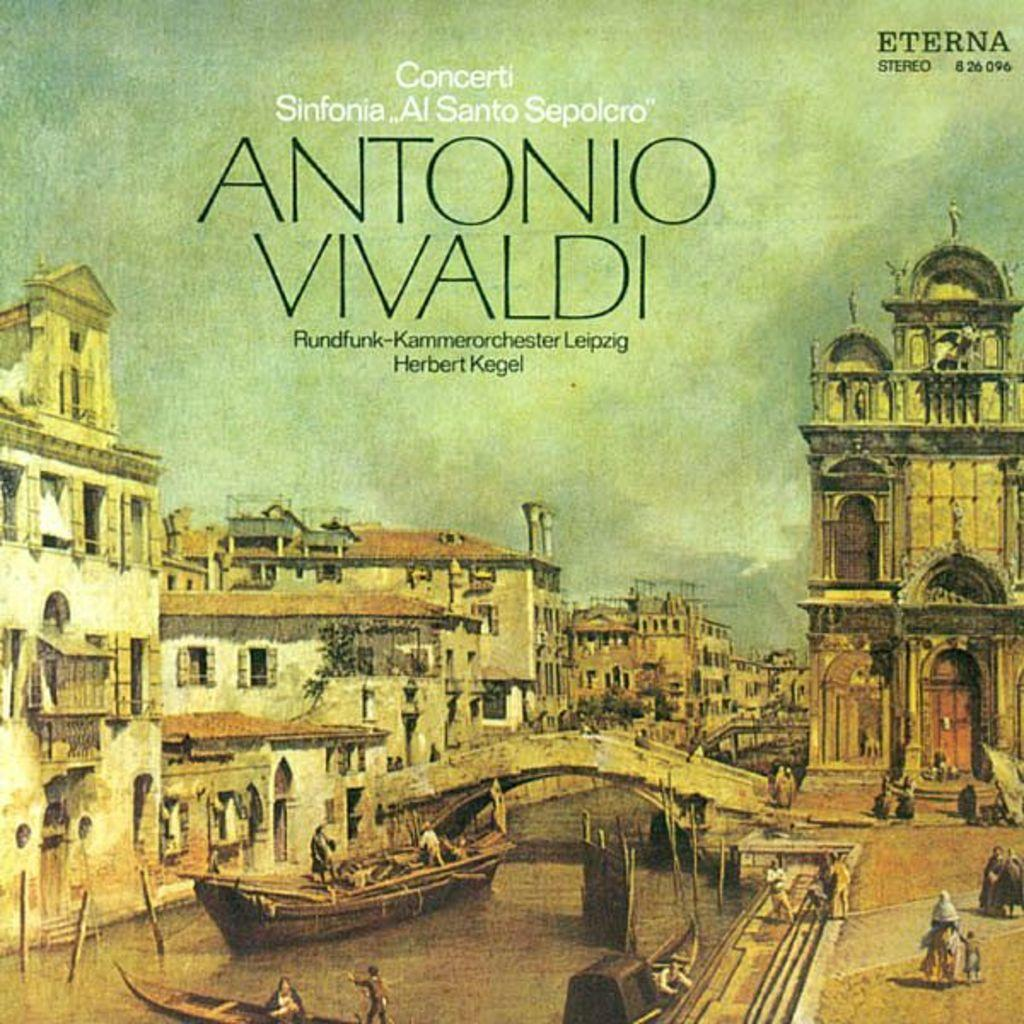Provide a one-sentence caption for the provided image. A record case for Antonio Vivaldi shows the iconic scene of people traveling in a Gondola in an Italian City. 